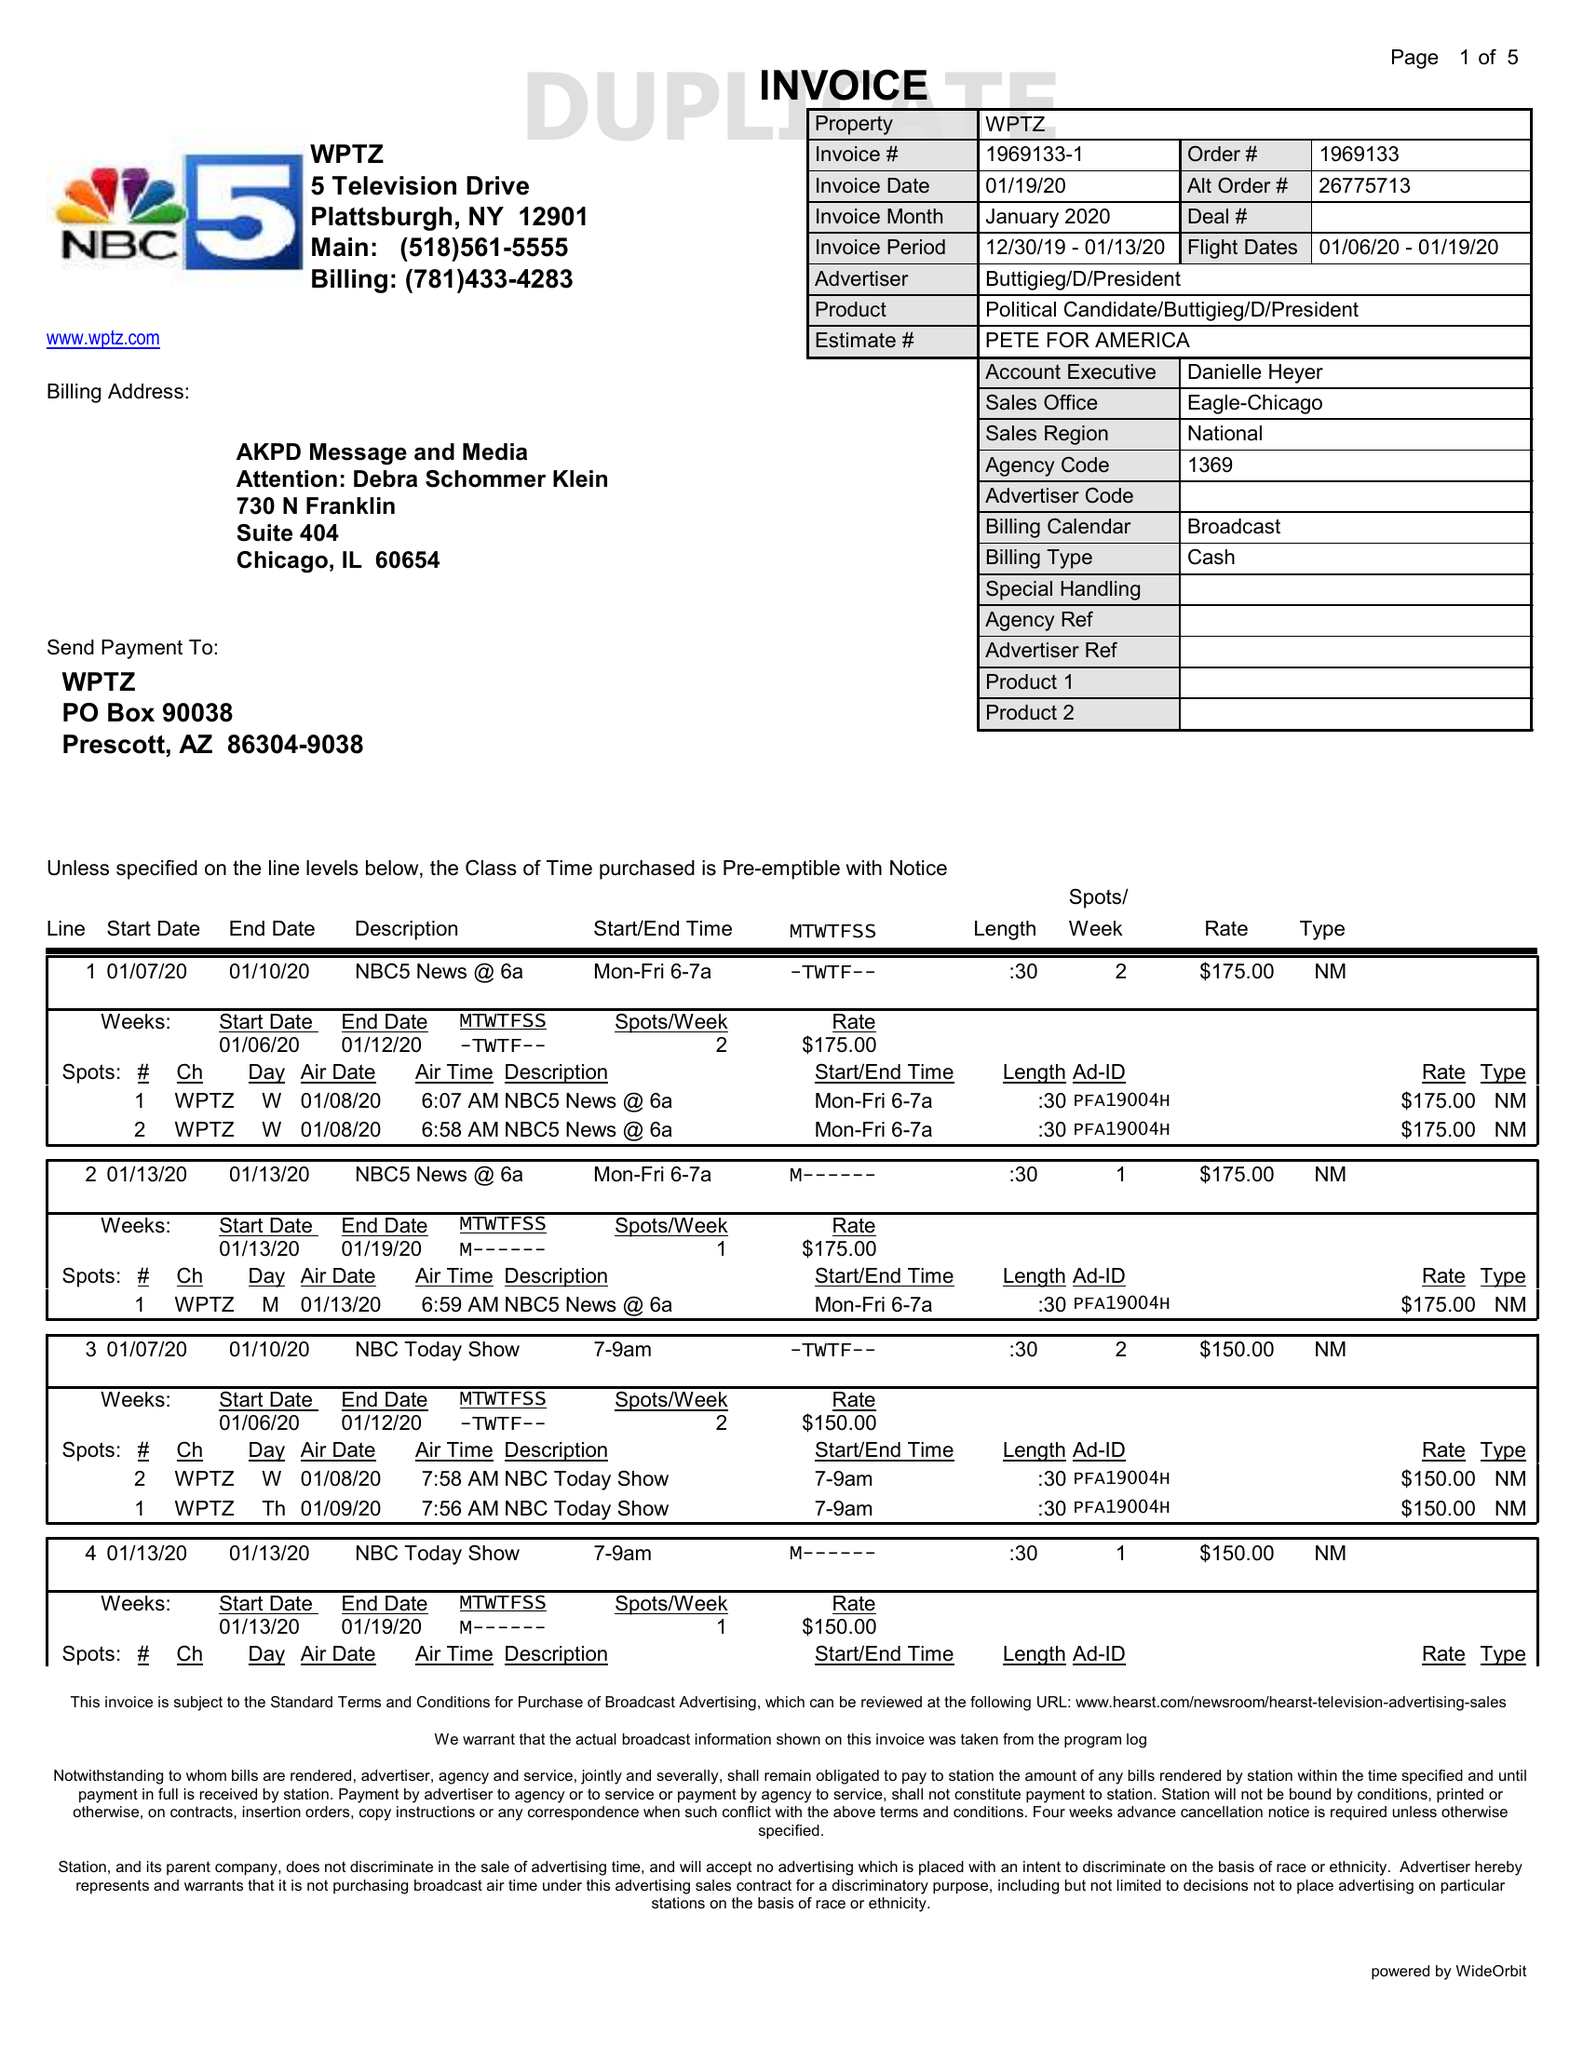What is the value for the flight_to?
Answer the question using a single word or phrase. 01/19/20 